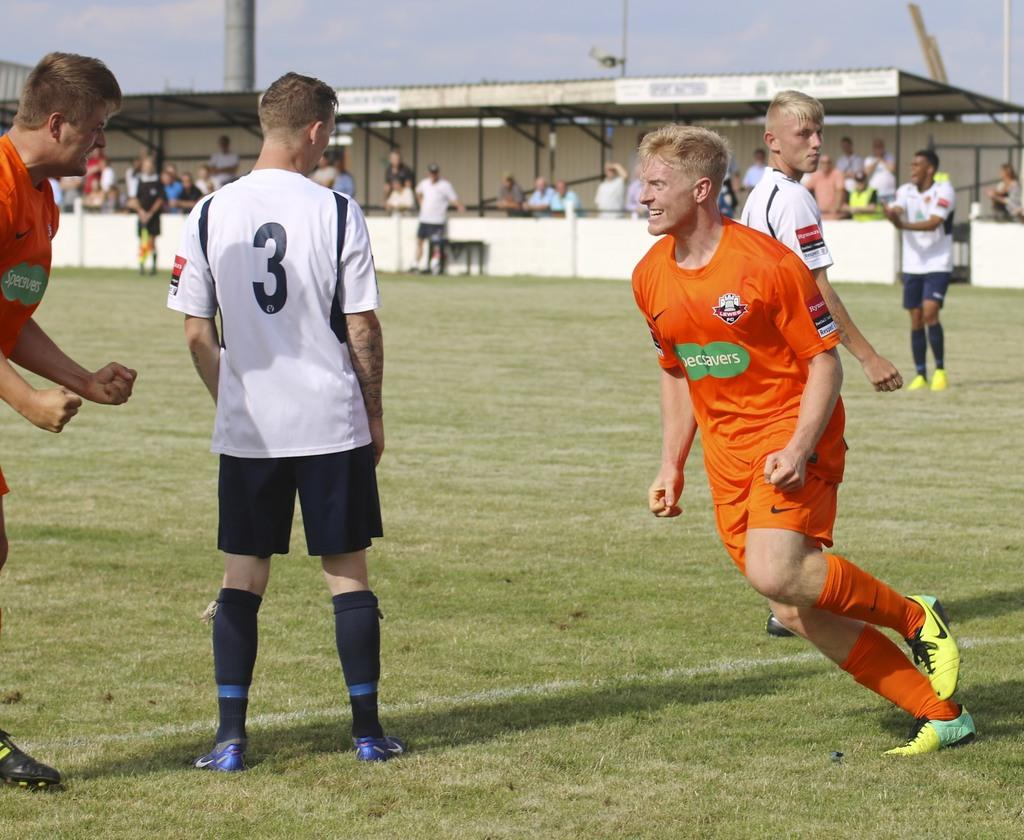<image>
Render a clear and concise summary of the photo. two players in orange with specsavers emblem on front run toward number 3 in white 